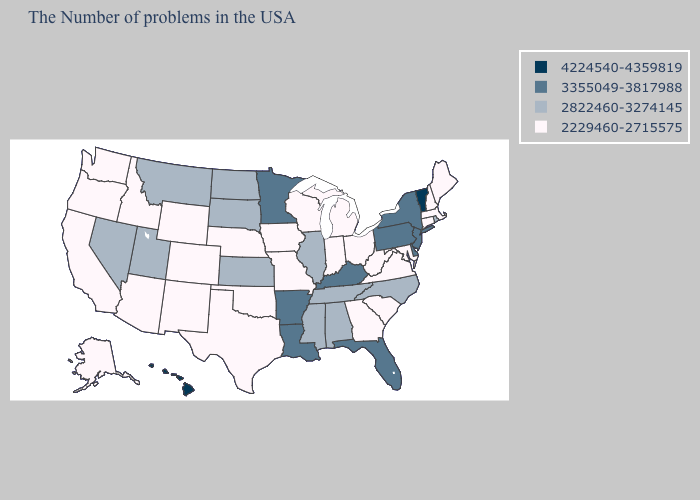Does the first symbol in the legend represent the smallest category?
Short answer required. No. Does Michigan have a lower value than Hawaii?
Answer briefly. Yes. Which states hav the highest value in the MidWest?
Be succinct. Minnesota. What is the value of Utah?
Short answer required. 2822460-3274145. Among the states that border Massachusetts , which have the highest value?
Quick response, please. Vermont. Does Hawaii have the highest value in the USA?
Be succinct. Yes. What is the value of Rhode Island?
Short answer required. 2822460-3274145. Among the states that border New York , which have the highest value?
Quick response, please. Vermont. Does Minnesota have the highest value in the MidWest?
Keep it brief. Yes. What is the value of Pennsylvania?
Short answer required. 3355049-3817988. Does Nebraska have the highest value in the USA?
Short answer required. No. What is the value of Nebraska?
Give a very brief answer. 2229460-2715575. Does Maryland have the same value as Kansas?
Be succinct. No. Is the legend a continuous bar?
Quick response, please. No. Name the states that have a value in the range 2822460-3274145?
Be succinct. Rhode Island, North Carolina, Alabama, Tennessee, Illinois, Mississippi, Kansas, South Dakota, North Dakota, Utah, Montana, Nevada. 